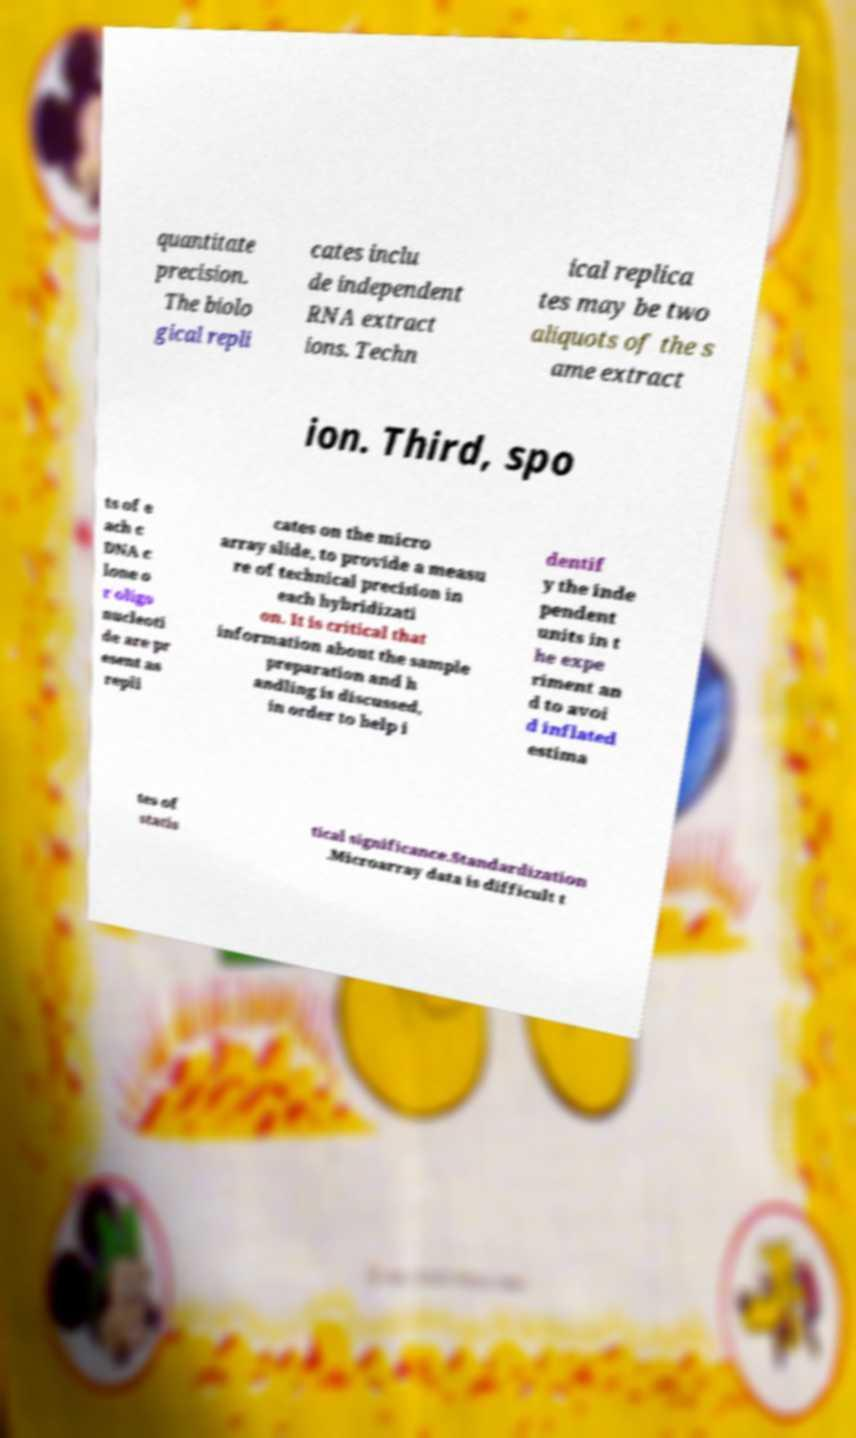Could you assist in decoding the text presented in this image and type it out clearly? quantitate precision. The biolo gical repli cates inclu de independent RNA extract ions. Techn ical replica tes may be two aliquots of the s ame extract ion. Third, spo ts of e ach c DNA c lone o r oligo nucleoti de are pr esent as repli cates on the micro array slide, to provide a measu re of technical precision in each hybridizati on. It is critical that information about the sample preparation and h andling is discussed, in order to help i dentif y the inde pendent units in t he expe riment an d to avoi d inflated estima tes of statis tical significance.Standardization .Microarray data is difficult t 